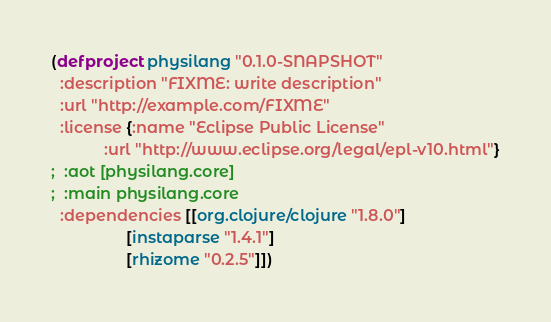Convert code to text. <code><loc_0><loc_0><loc_500><loc_500><_Clojure_>(defproject physilang "0.1.0-SNAPSHOT"
  :description "FIXME: write description"
  :url "http://example.com/FIXME"
  :license {:name "Eclipse Public License"
            :url "http://www.eclipse.org/legal/epl-v10.html"}
;  :aot [physilang.core]
;  :main physilang.core 
  :dependencies [[org.clojure/clojure "1.8.0"]
                 [instaparse "1.4.1"]
                 [rhizome "0.2.5"]])
</code> 